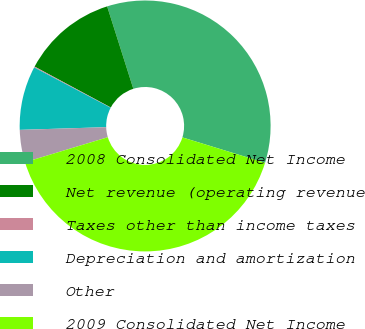<chart> <loc_0><loc_0><loc_500><loc_500><pie_chart><fcel>2008 Consolidated Net Income<fcel>Net revenue (operating revenue<fcel>Taxes other than income taxes<fcel>Depreciation and amortization<fcel>Other<fcel>2009 Consolidated Net Income<nl><fcel>34.64%<fcel>12.26%<fcel>0.12%<fcel>8.22%<fcel>4.17%<fcel>40.58%<nl></chart> 